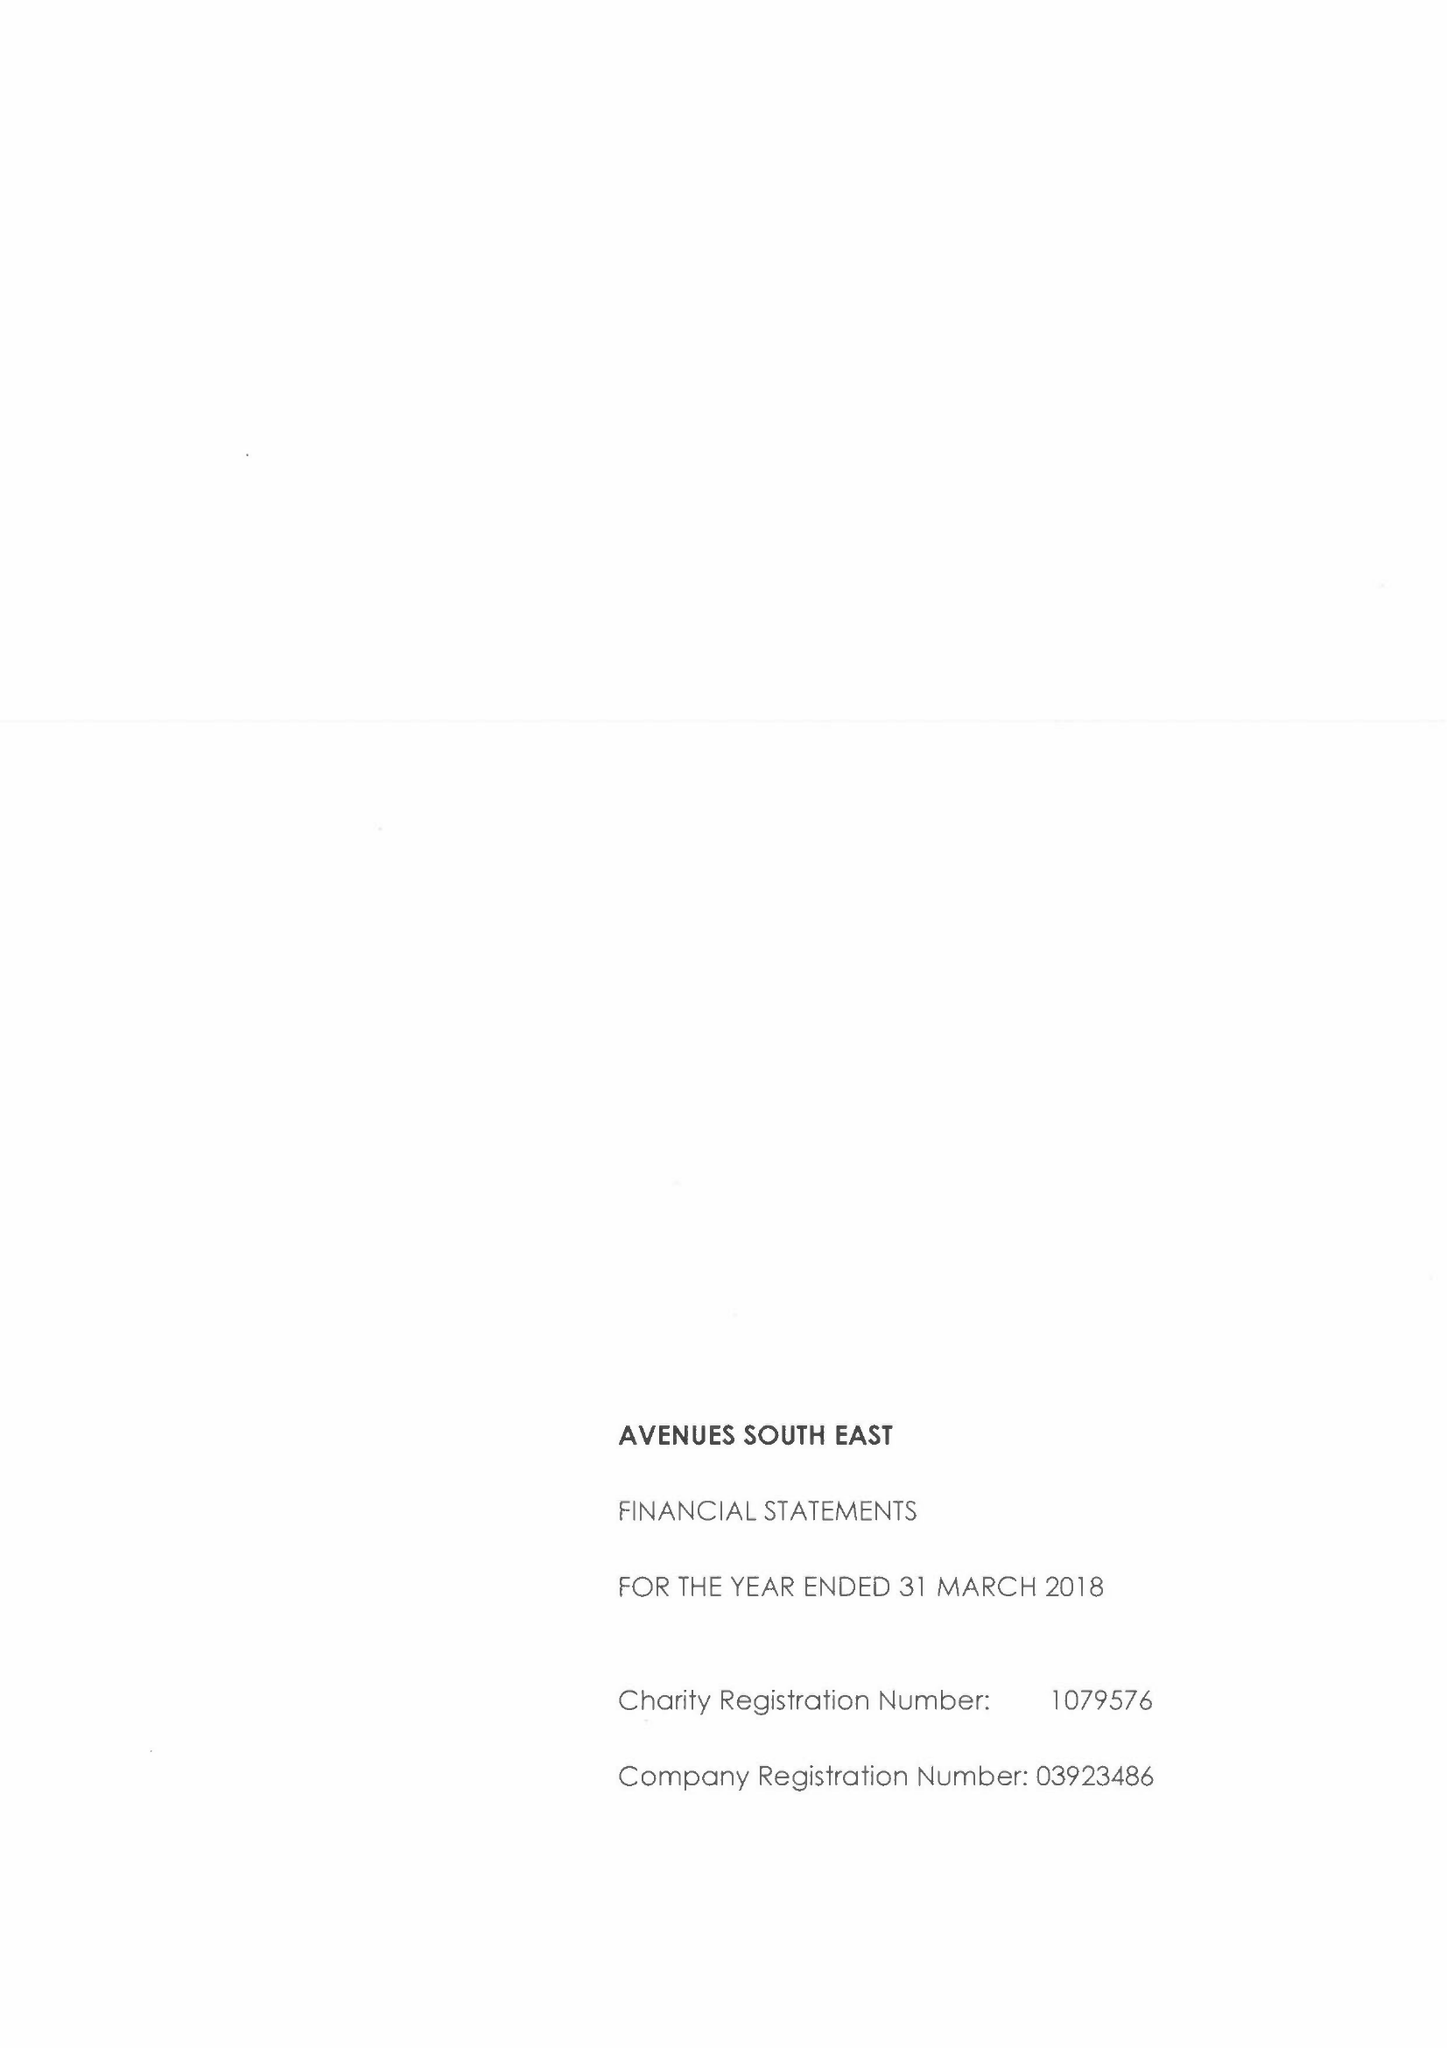What is the value for the address__post_town?
Answer the question using a single word or phrase. SIDCUP 